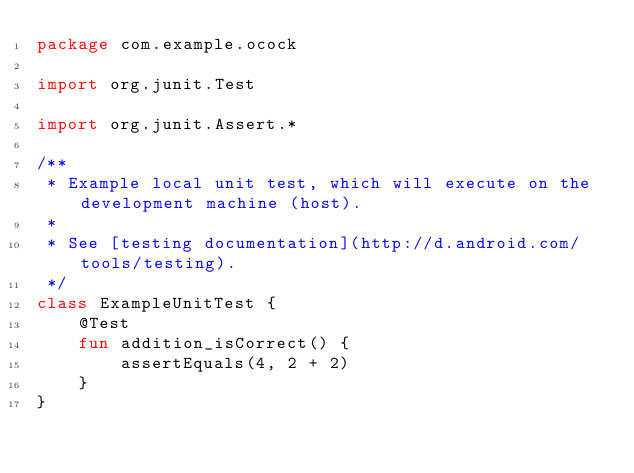Convert code to text. <code><loc_0><loc_0><loc_500><loc_500><_Kotlin_>package com.example.ocock

import org.junit.Test

import org.junit.Assert.*

/**
 * Example local unit test, which will execute on the development machine (host).
 *
 * See [testing documentation](http://d.android.com/tools/testing).
 */
class ExampleUnitTest {
    @Test
    fun addition_isCorrect() {
        assertEquals(4, 2 + 2)
    }
}
</code> 